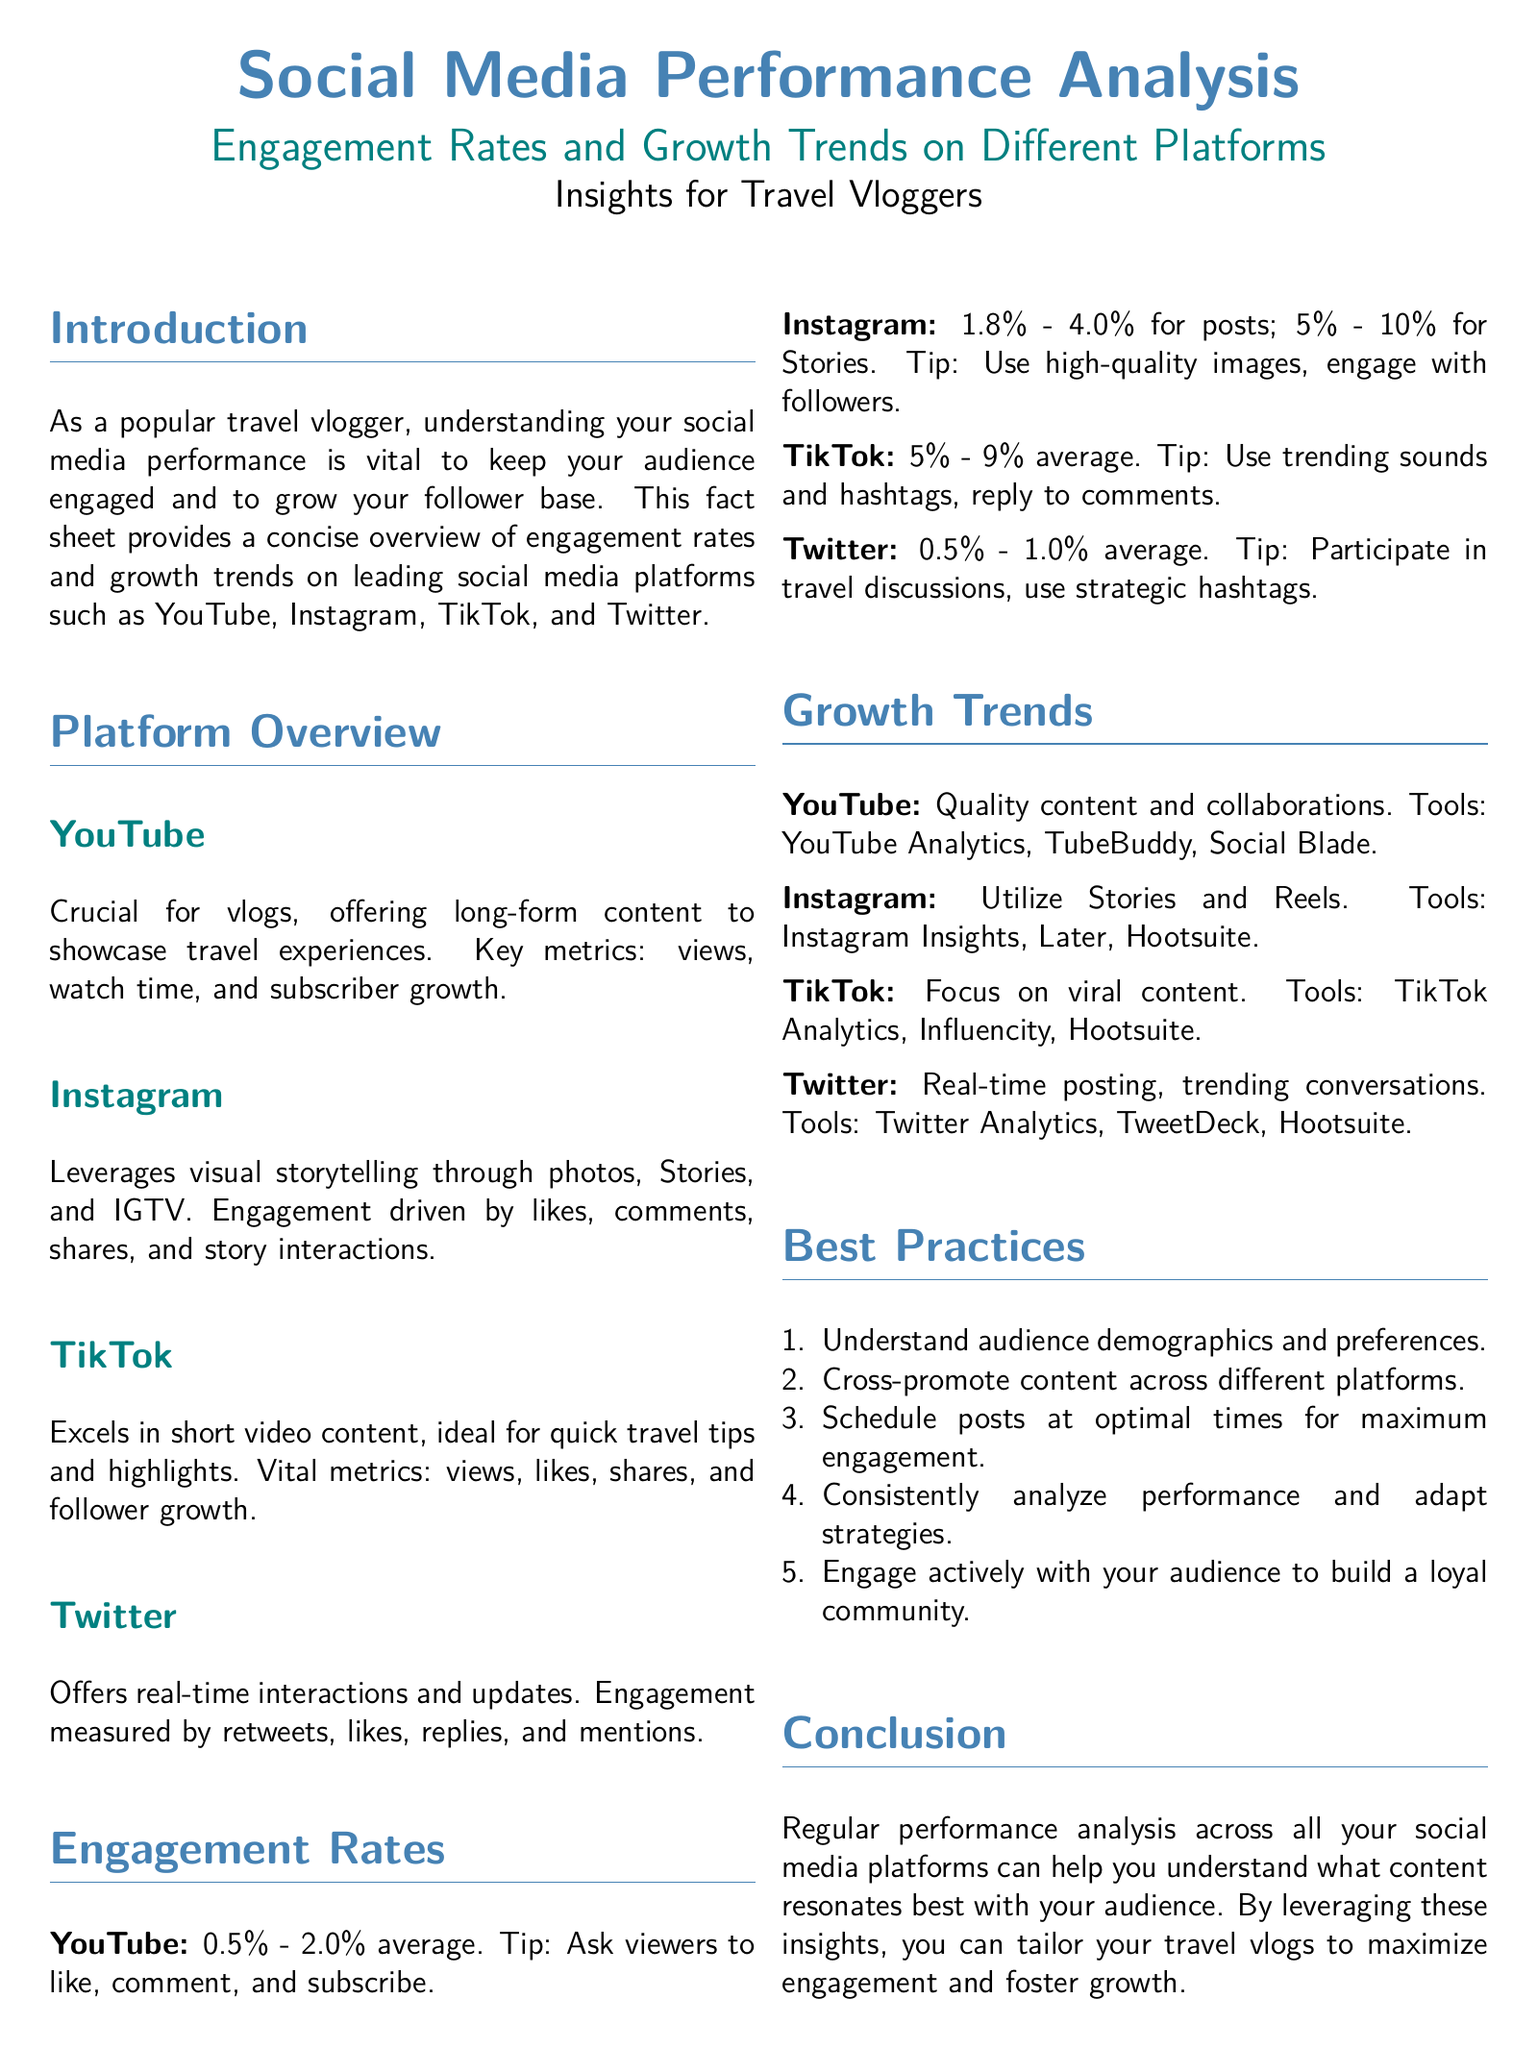What is the average engagement rate on YouTube? The engagement rate on YouTube ranges from 0.5% to 2.0%.
Answer: 0.5% - 2.0% What metric is crucial for Instagram engagement? Instagram engagement is driven by likes, comments, shares, and story interactions.
Answer: Likes, comments, shares, and story interactions Which platform has the highest average engagement rate? TikTok has an engagement rate of 5% to 9%, which is the highest among the listed platforms.
Answer: 5% - 9% What is a recommended tool for analyzing growth trends on TikTok? TikTok Analytics is suggested for analyzing growth trends on that platform.
Answer: TikTok Analytics What are the optimal engagement rates for Instagram Stories? The engagement rates for Instagram Stories range from 5% to 10%.
Answer: 5% - 10% Which type of content is emphasized for growth on YouTube? Quality content and collaborations are emphasized for growth on YouTube.
Answer: Quality content and collaborations What should travel vloggers do to foster growth according to the Best Practices? Travel vloggers should engage actively with their audience to build a loyal community.
Answer: Engage actively with your audience What engagement metric does Twitter focus on? Twitter measures engagement through retweets, likes, replies, and mentions.
Answer: Retweets, likes, replies, and mentions What is an effective strategy mentioned for TikTok content? Focusing on viral content is an effective strategy for TikTok.
Answer: Viral content 